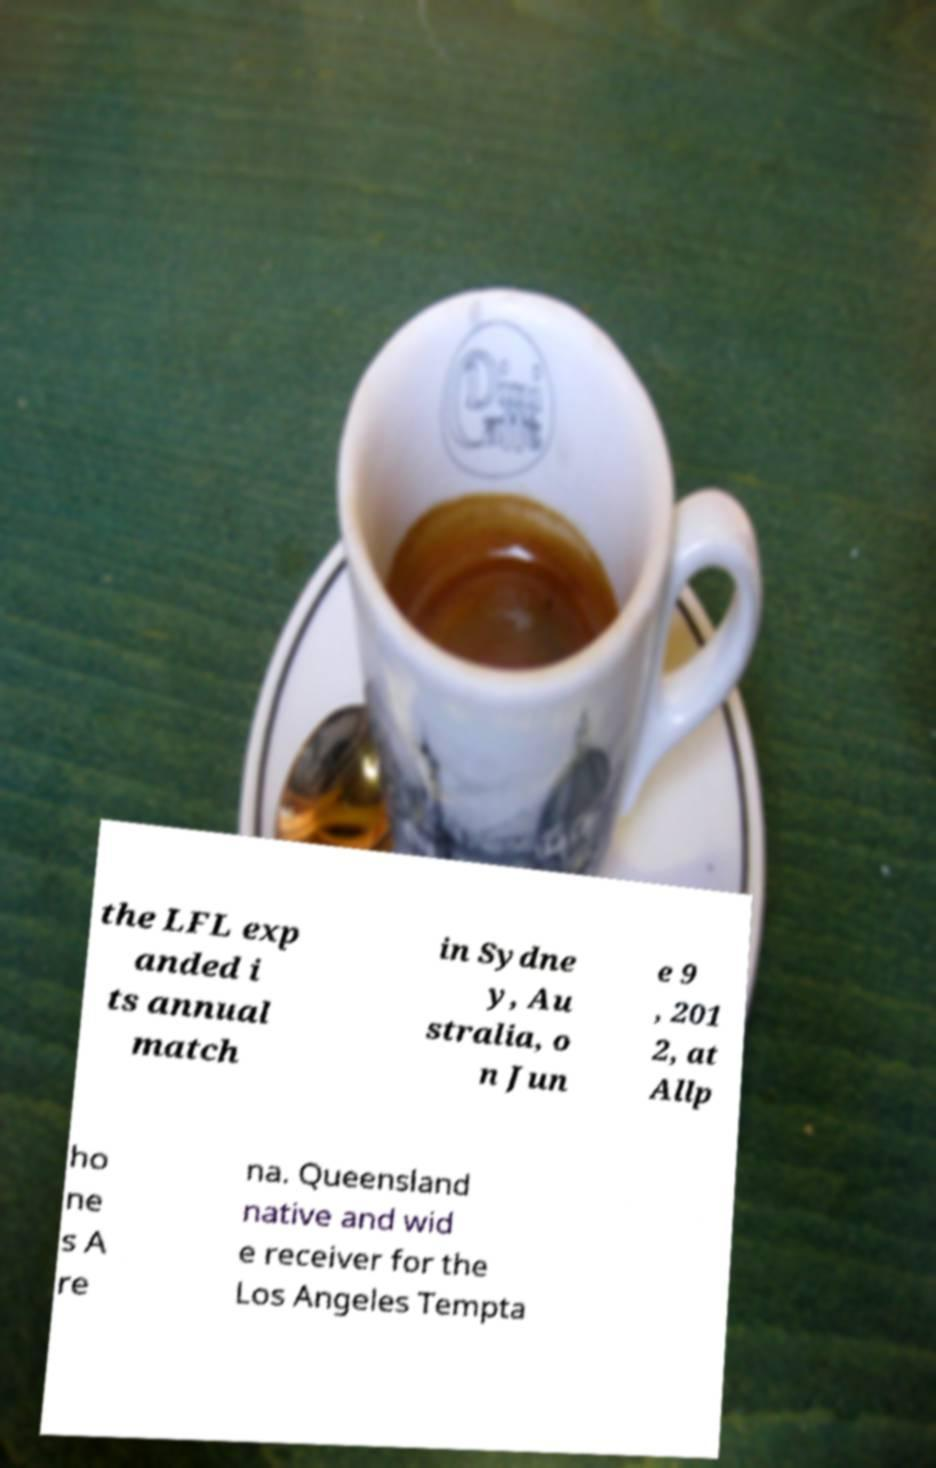What messages or text are displayed in this image? I need them in a readable, typed format. the LFL exp anded i ts annual match in Sydne y, Au stralia, o n Jun e 9 , 201 2, at Allp ho ne s A re na. Queensland native and wid e receiver for the Los Angeles Tempta 